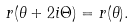<formula> <loc_0><loc_0><loc_500><loc_500>r ( \theta + 2 i \Theta ) = r ( \theta ) .</formula> 